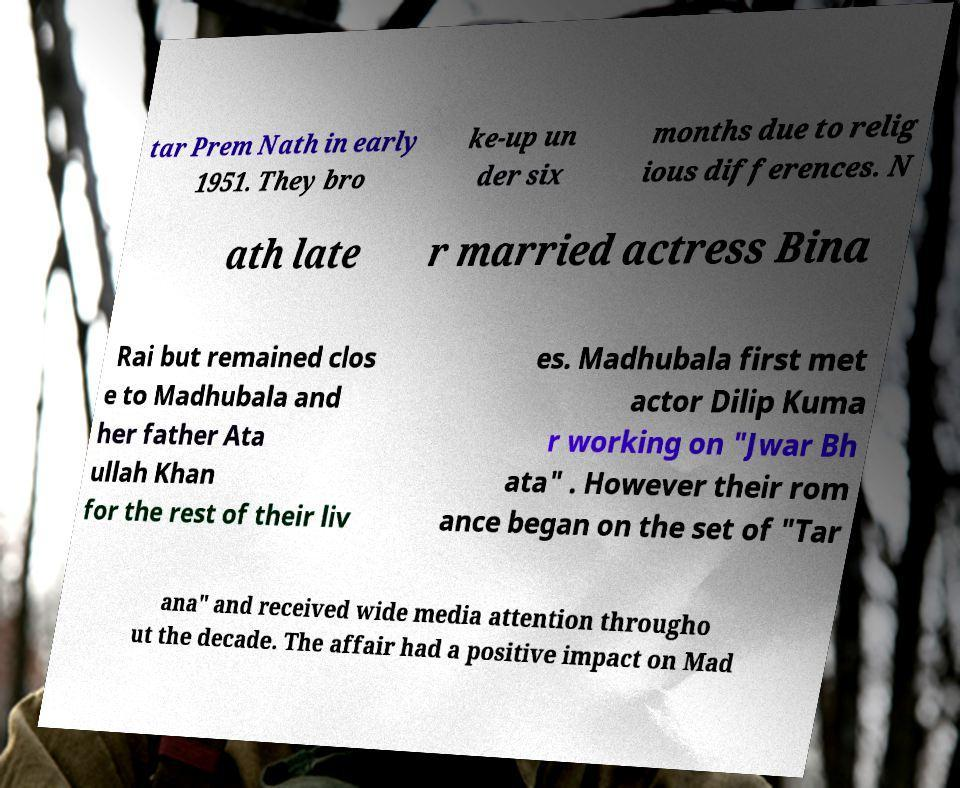There's text embedded in this image that I need extracted. Can you transcribe it verbatim? tar Prem Nath in early 1951. They bro ke-up un der six months due to relig ious differences. N ath late r married actress Bina Rai but remained clos e to Madhubala and her father Ata ullah Khan for the rest of their liv es. Madhubala first met actor Dilip Kuma r working on "Jwar Bh ata" . However their rom ance began on the set of "Tar ana" and received wide media attention througho ut the decade. The affair had a positive impact on Mad 